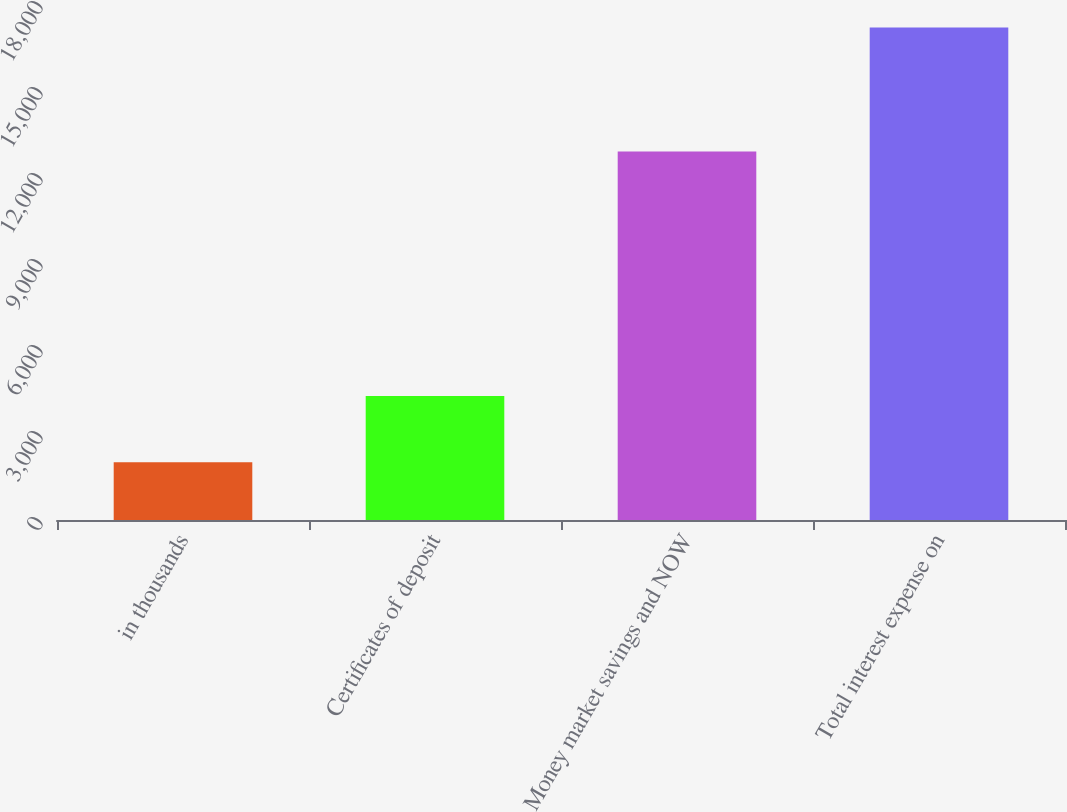Convert chart to OTSL. <chart><loc_0><loc_0><loc_500><loc_500><bar_chart><fcel>in thousands<fcel>Certificates of deposit<fcel>Money market savings and NOW<fcel>Total interest expense on<nl><fcel>2017<fcel>4325<fcel>12859<fcel>17184<nl></chart> 